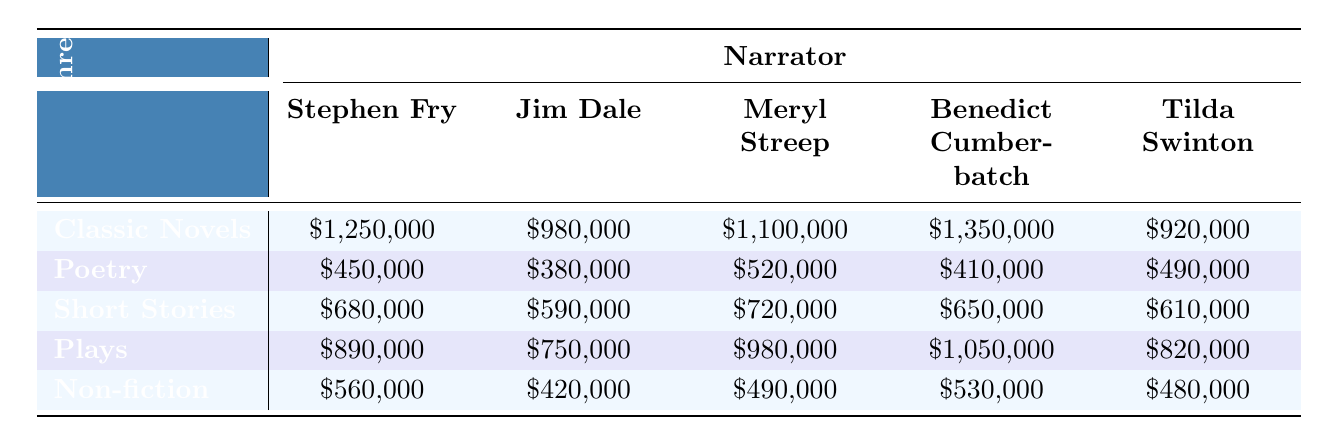What is the highest revenue generated by a single narrator in the genre of Classic Novels? In the Classic Novels genre, the revenues for each narrator are: Stephen Fry: $1,250,000, Jim Dale: $980,000, Meryl Streep: $1,100,000, Benedict Cumberbatch: $1,350,000, and Tilda Swinton: $920,000. The highest among these is $1,350,000 from Benedict Cumberbatch.
Answer: $1,350,000 Which genre of audiobooks has the lowest total revenue across all narrators? To find the genre with the lowest total revenue, I need to sum the revenues for each genre: Poetry ($450,000 + $380,000 + $520,000 + $410,000 + $490,000 = $2,250,000), Short Stories ($680,000 + $590,000 + $720,000 + $650,000 + $610,000 = $3,250,000), Plays ($890,000 + $750,000 + $980,000 + $1,050,000 + $820,000 = $4,490,000), and Non-fiction ($560,000 + $420,000 + $490,000 + $530,000 + $480,000 = $2,480,000). The lowest total revenue is from the Poetry genre with $2,250,000.
Answer: Poetry What is the average revenue contribution of Stephen Fry across all genres? The revenues for Stephen Fry are: Classic Novels: $1,250,000, Poetry: $450,000, Short Stories: $680,000, Plays: $890,000, Non-fiction: $560,000. Summing these gives $1,250,000 + $450,000 + $680,000 + $890,000 + $560,000 = $3,830,000. The average is then $3,830,000 divided by 5 genres = $766,000.
Answer: $766,000 Is there any narrator who has the highest revenue in all genres? Checking the highest revenues for each genre: Classic Novels - Benedict Cumberbatch: $1,350,000; Poetry - Meryl Streep: $520,000; Short Stories - Meryl Streep: $720,000; Plays - Benedict Cumberbatch: $1,050,000; Non-fiction - Benedict Cumberbatch: $530,000. No single narrator holds the highest revenue in all genres, as the top narrator varies by category.
Answer: No Which narrator earned the most from the genre of Plays? The revenue for the Plays genre is: Stephen Fry: $890,000, Jim Dale: $750,000, Meryl Streep: $980,000, Benedict Cumberbatch: $1,050,000, Tilda Swinton: $820,000. The highest revenue is $1,050,000 from Benedict Cumberbatch.
Answer: $1,050,000 If I combine the revenues from Short Stories and Poetry, which narrator earns the most? The revenues in Poetry are: Stephen Fry: $450,000, Jim Dale: $380,000, Meryl Streep: $520,000, Benedict Cumberbatch: $410,000, Tilda Swinton: $490,000; for Short Stories: Stephen Fry: $680,000, Jim Dale: $590,000, Meryl Streep: $720,000, Benedict Cumberbatch: $650,000, Tilda Swinton: $610,000. Combining these data point by point gives: Stephen Fry: $1,130,000, Jim Dale: $970,000, Meryl Streep: $1,240,000, Benedict Cumberbatch: $1,060,000, Tilda Swinton: $1,100,000. The highest is $1,240,000 from Meryl Streep.
Answer: $1,240,000 